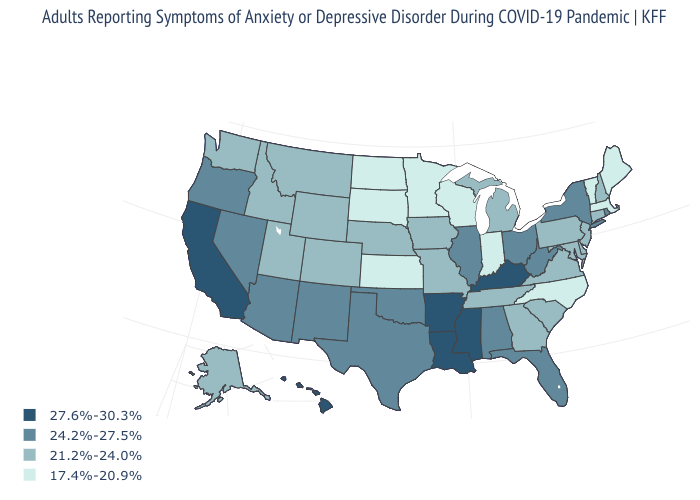Among the states that border Oregon , which have the highest value?
Quick response, please. California. What is the value of New Mexico?
Be succinct. 24.2%-27.5%. What is the highest value in the South ?
Answer briefly. 27.6%-30.3%. Name the states that have a value in the range 17.4%-20.9%?
Give a very brief answer. Indiana, Kansas, Maine, Massachusetts, Minnesota, North Carolina, North Dakota, South Dakota, Vermont, Wisconsin. Does Maine have a lower value than South Dakota?
Write a very short answer. No. Name the states that have a value in the range 21.2%-24.0%?
Write a very short answer. Alaska, Colorado, Connecticut, Delaware, Georgia, Idaho, Iowa, Maryland, Michigan, Missouri, Montana, Nebraska, New Hampshire, New Jersey, Pennsylvania, South Carolina, Tennessee, Utah, Virginia, Washington, Wyoming. Name the states that have a value in the range 24.2%-27.5%?
Short answer required. Alabama, Arizona, Florida, Illinois, Nevada, New Mexico, New York, Ohio, Oklahoma, Oregon, Rhode Island, Texas, West Virginia. How many symbols are there in the legend?
Answer briefly. 4. Name the states that have a value in the range 21.2%-24.0%?
Quick response, please. Alaska, Colorado, Connecticut, Delaware, Georgia, Idaho, Iowa, Maryland, Michigan, Missouri, Montana, Nebraska, New Hampshire, New Jersey, Pennsylvania, South Carolina, Tennessee, Utah, Virginia, Washington, Wyoming. Which states have the highest value in the USA?
Keep it brief. Arkansas, California, Hawaii, Kentucky, Louisiana, Mississippi. Which states have the lowest value in the South?
Answer briefly. North Carolina. Which states have the lowest value in the South?
Short answer required. North Carolina. Does California have a higher value than Ohio?
Quick response, please. Yes. What is the value of Iowa?
Give a very brief answer. 21.2%-24.0%. Does Louisiana have a lower value than Nevada?
Keep it brief. No. 